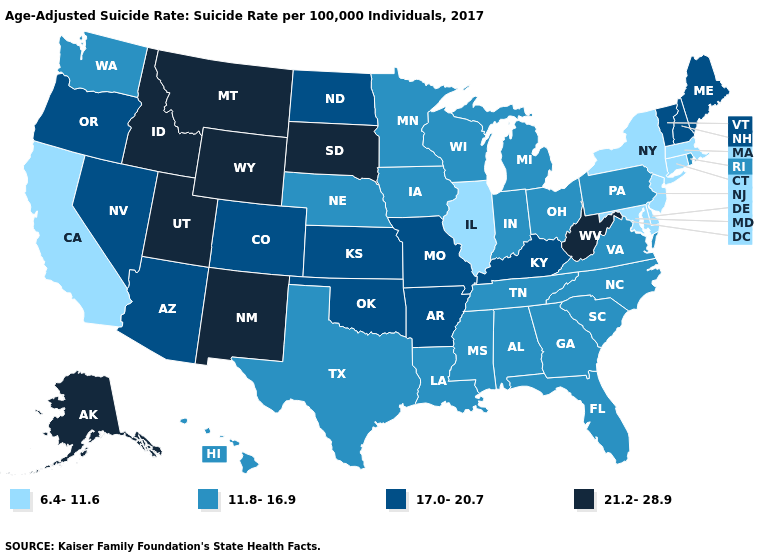Name the states that have a value in the range 17.0-20.7?
Give a very brief answer. Arizona, Arkansas, Colorado, Kansas, Kentucky, Maine, Missouri, Nevada, New Hampshire, North Dakota, Oklahoma, Oregon, Vermont. Which states hav the highest value in the West?
Give a very brief answer. Alaska, Idaho, Montana, New Mexico, Utah, Wyoming. Does Maine have the highest value in the Northeast?
Quick response, please. Yes. Does Delaware have the lowest value in the USA?
Keep it brief. Yes. Does Missouri have the lowest value in the MidWest?
Quick response, please. No. Does Wyoming have the highest value in the USA?
Short answer required. Yes. Among the states that border West Virginia , does Virginia have the highest value?
Be succinct. No. Name the states that have a value in the range 11.8-16.9?
Be succinct. Alabama, Florida, Georgia, Hawaii, Indiana, Iowa, Louisiana, Michigan, Minnesota, Mississippi, Nebraska, North Carolina, Ohio, Pennsylvania, Rhode Island, South Carolina, Tennessee, Texas, Virginia, Washington, Wisconsin. Which states hav the highest value in the West?
Write a very short answer. Alaska, Idaho, Montana, New Mexico, Utah, Wyoming. What is the value of Nebraska?
Write a very short answer. 11.8-16.9. Name the states that have a value in the range 6.4-11.6?
Be succinct. California, Connecticut, Delaware, Illinois, Maryland, Massachusetts, New Jersey, New York. Among the states that border Illinois , which have the lowest value?
Answer briefly. Indiana, Iowa, Wisconsin. Which states have the lowest value in the West?
Quick response, please. California. Does New Hampshire have the highest value in the Northeast?
Be succinct. Yes. What is the value of Connecticut?
Concise answer only. 6.4-11.6. 